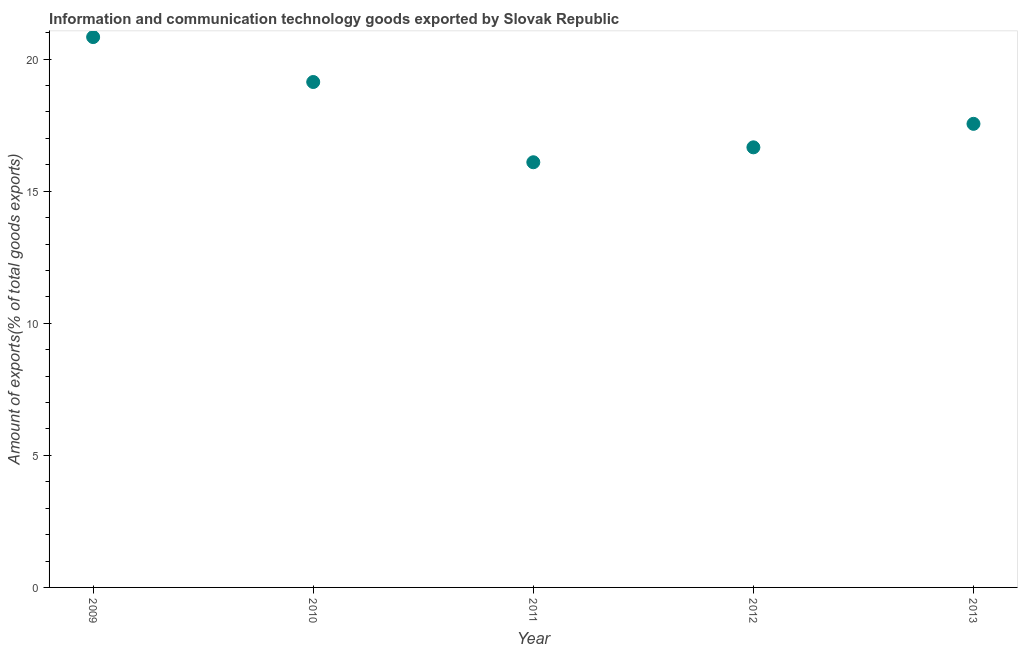What is the amount of ict goods exports in 2011?
Give a very brief answer. 16.1. Across all years, what is the maximum amount of ict goods exports?
Provide a short and direct response. 20.83. Across all years, what is the minimum amount of ict goods exports?
Your response must be concise. 16.1. In which year was the amount of ict goods exports minimum?
Your answer should be very brief. 2011. What is the sum of the amount of ict goods exports?
Keep it short and to the point. 90.27. What is the difference between the amount of ict goods exports in 2009 and 2013?
Offer a very short reply. 3.28. What is the average amount of ict goods exports per year?
Your answer should be very brief. 18.05. What is the median amount of ict goods exports?
Your answer should be compact. 17.55. Do a majority of the years between 2010 and 2012 (inclusive) have amount of ict goods exports greater than 4 %?
Give a very brief answer. Yes. What is the ratio of the amount of ict goods exports in 2009 to that in 2013?
Your response must be concise. 1.19. Is the difference between the amount of ict goods exports in 2009 and 2010 greater than the difference between any two years?
Give a very brief answer. No. What is the difference between the highest and the second highest amount of ict goods exports?
Ensure brevity in your answer.  1.7. Is the sum of the amount of ict goods exports in 2010 and 2013 greater than the maximum amount of ict goods exports across all years?
Provide a succinct answer. Yes. What is the difference between the highest and the lowest amount of ict goods exports?
Provide a short and direct response. 4.74. In how many years, is the amount of ict goods exports greater than the average amount of ict goods exports taken over all years?
Offer a terse response. 2. How many years are there in the graph?
Offer a terse response. 5. Does the graph contain grids?
Ensure brevity in your answer.  No. What is the title of the graph?
Offer a terse response. Information and communication technology goods exported by Slovak Republic. What is the label or title of the X-axis?
Provide a succinct answer. Year. What is the label or title of the Y-axis?
Your response must be concise. Amount of exports(% of total goods exports). What is the Amount of exports(% of total goods exports) in 2009?
Your answer should be compact. 20.83. What is the Amount of exports(% of total goods exports) in 2010?
Ensure brevity in your answer.  19.13. What is the Amount of exports(% of total goods exports) in 2011?
Your response must be concise. 16.1. What is the Amount of exports(% of total goods exports) in 2012?
Your answer should be very brief. 16.66. What is the Amount of exports(% of total goods exports) in 2013?
Your response must be concise. 17.55. What is the difference between the Amount of exports(% of total goods exports) in 2009 and 2010?
Give a very brief answer. 1.7. What is the difference between the Amount of exports(% of total goods exports) in 2009 and 2011?
Provide a short and direct response. 4.74. What is the difference between the Amount of exports(% of total goods exports) in 2009 and 2012?
Make the answer very short. 4.17. What is the difference between the Amount of exports(% of total goods exports) in 2009 and 2013?
Ensure brevity in your answer.  3.28. What is the difference between the Amount of exports(% of total goods exports) in 2010 and 2011?
Your answer should be very brief. 3.04. What is the difference between the Amount of exports(% of total goods exports) in 2010 and 2012?
Provide a succinct answer. 2.47. What is the difference between the Amount of exports(% of total goods exports) in 2010 and 2013?
Ensure brevity in your answer.  1.58. What is the difference between the Amount of exports(% of total goods exports) in 2011 and 2012?
Offer a very short reply. -0.56. What is the difference between the Amount of exports(% of total goods exports) in 2011 and 2013?
Make the answer very short. -1.45. What is the difference between the Amount of exports(% of total goods exports) in 2012 and 2013?
Your answer should be very brief. -0.89. What is the ratio of the Amount of exports(% of total goods exports) in 2009 to that in 2010?
Give a very brief answer. 1.09. What is the ratio of the Amount of exports(% of total goods exports) in 2009 to that in 2011?
Offer a very short reply. 1.29. What is the ratio of the Amount of exports(% of total goods exports) in 2009 to that in 2012?
Give a very brief answer. 1.25. What is the ratio of the Amount of exports(% of total goods exports) in 2009 to that in 2013?
Keep it short and to the point. 1.19. What is the ratio of the Amount of exports(% of total goods exports) in 2010 to that in 2011?
Provide a short and direct response. 1.19. What is the ratio of the Amount of exports(% of total goods exports) in 2010 to that in 2012?
Ensure brevity in your answer.  1.15. What is the ratio of the Amount of exports(% of total goods exports) in 2010 to that in 2013?
Ensure brevity in your answer.  1.09. What is the ratio of the Amount of exports(% of total goods exports) in 2011 to that in 2012?
Provide a short and direct response. 0.97. What is the ratio of the Amount of exports(% of total goods exports) in 2011 to that in 2013?
Offer a very short reply. 0.92. What is the ratio of the Amount of exports(% of total goods exports) in 2012 to that in 2013?
Offer a terse response. 0.95. 